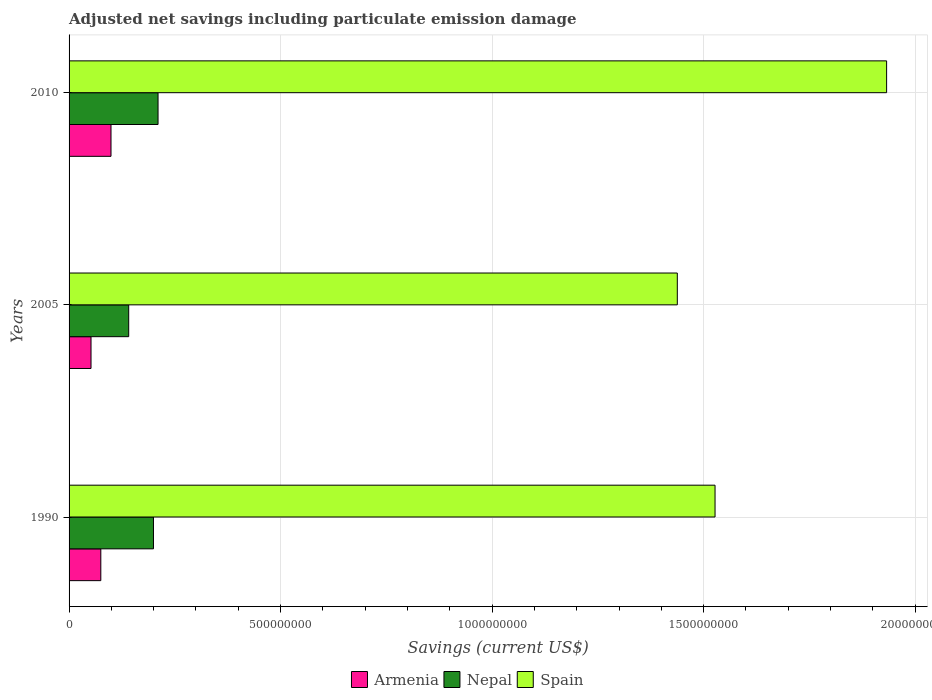How many different coloured bars are there?
Provide a short and direct response. 3. How many groups of bars are there?
Ensure brevity in your answer.  3. Are the number of bars per tick equal to the number of legend labels?
Give a very brief answer. Yes. Are the number of bars on each tick of the Y-axis equal?
Your response must be concise. Yes. How many bars are there on the 3rd tick from the top?
Keep it short and to the point. 3. How many bars are there on the 2nd tick from the bottom?
Your answer should be very brief. 3. What is the label of the 1st group of bars from the top?
Provide a succinct answer. 2010. In how many cases, is the number of bars for a given year not equal to the number of legend labels?
Keep it short and to the point. 0. What is the net savings in Armenia in 1990?
Your answer should be compact. 7.50e+07. Across all years, what is the maximum net savings in Armenia?
Your response must be concise. 9.91e+07. Across all years, what is the minimum net savings in Armenia?
Make the answer very short. 5.19e+07. In which year was the net savings in Spain maximum?
Ensure brevity in your answer.  2010. What is the total net savings in Armenia in the graph?
Provide a short and direct response. 2.26e+08. What is the difference between the net savings in Spain in 1990 and that in 2010?
Your response must be concise. -4.06e+08. What is the difference between the net savings in Armenia in 1990 and the net savings in Spain in 2010?
Make the answer very short. -1.86e+09. What is the average net savings in Nepal per year?
Your answer should be very brief. 1.84e+08. In the year 2010, what is the difference between the net savings in Nepal and net savings in Armenia?
Your response must be concise. 1.11e+08. In how many years, is the net savings in Spain greater than 1400000000 US$?
Offer a very short reply. 3. What is the ratio of the net savings in Nepal in 1990 to that in 2005?
Offer a terse response. 1.42. Is the difference between the net savings in Nepal in 2005 and 2010 greater than the difference between the net savings in Armenia in 2005 and 2010?
Offer a very short reply. No. What is the difference between the highest and the second highest net savings in Armenia?
Keep it short and to the point. 2.41e+07. What is the difference between the highest and the lowest net savings in Spain?
Offer a terse response. 4.95e+08. Is the sum of the net savings in Spain in 2005 and 2010 greater than the maximum net savings in Nepal across all years?
Provide a short and direct response. Yes. What does the 3rd bar from the top in 2005 represents?
Your answer should be compact. Armenia. What does the 2nd bar from the bottom in 1990 represents?
Provide a succinct answer. Nepal. Is it the case that in every year, the sum of the net savings in Spain and net savings in Armenia is greater than the net savings in Nepal?
Provide a succinct answer. Yes. How many years are there in the graph?
Ensure brevity in your answer.  3. What is the difference between two consecutive major ticks on the X-axis?
Make the answer very short. 5.00e+08. Where does the legend appear in the graph?
Offer a very short reply. Bottom center. How many legend labels are there?
Offer a very short reply. 3. How are the legend labels stacked?
Your answer should be compact. Horizontal. What is the title of the graph?
Give a very brief answer. Adjusted net savings including particulate emission damage. Does "Suriname" appear as one of the legend labels in the graph?
Your answer should be very brief. No. What is the label or title of the X-axis?
Offer a terse response. Savings (current US$). What is the label or title of the Y-axis?
Offer a terse response. Years. What is the Savings (current US$) of Armenia in 1990?
Make the answer very short. 7.50e+07. What is the Savings (current US$) in Nepal in 1990?
Make the answer very short. 2.00e+08. What is the Savings (current US$) in Spain in 1990?
Offer a very short reply. 1.53e+09. What is the Savings (current US$) of Armenia in 2005?
Ensure brevity in your answer.  5.19e+07. What is the Savings (current US$) of Nepal in 2005?
Make the answer very short. 1.41e+08. What is the Savings (current US$) in Spain in 2005?
Your answer should be very brief. 1.44e+09. What is the Savings (current US$) in Armenia in 2010?
Make the answer very short. 9.91e+07. What is the Savings (current US$) of Nepal in 2010?
Provide a succinct answer. 2.10e+08. What is the Savings (current US$) in Spain in 2010?
Provide a short and direct response. 1.93e+09. Across all years, what is the maximum Savings (current US$) in Armenia?
Your answer should be very brief. 9.91e+07. Across all years, what is the maximum Savings (current US$) in Nepal?
Offer a terse response. 2.10e+08. Across all years, what is the maximum Savings (current US$) in Spain?
Make the answer very short. 1.93e+09. Across all years, what is the minimum Savings (current US$) in Armenia?
Provide a succinct answer. 5.19e+07. Across all years, what is the minimum Savings (current US$) in Nepal?
Keep it short and to the point. 1.41e+08. Across all years, what is the minimum Savings (current US$) of Spain?
Ensure brevity in your answer.  1.44e+09. What is the total Savings (current US$) of Armenia in the graph?
Offer a terse response. 2.26e+08. What is the total Savings (current US$) in Nepal in the graph?
Keep it short and to the point. 5.51e+08. What is the total Savings (current US$) of Spain in the graph?
Keep it short and to the point. 4.90e+09. What is the difference between the Savings (current US$) of Armenia in 1990 and that in 2005?
Provide a short and direct response. 2.32e+07. What is the difference between the Savings (current US$) in Nepal in 1990 and that in 2005?
Make the answer very short. 5.85e+07. What is the difference between the Savings (current US$) of Spain in 1990 and that in 2005?
Make the answer very short. 8.92e+07. What is the difference between the Savings (current US$) in Armenia in 1990 and that in 2010?
Ensure brevity in your answer.  -2.41e+07. What is the difference between the Savings (current US$) in Nepal in 1990 and that in 2010?
Offer a very short reply. -1.08e+07. What is the difference between the Savings (current US$) of Spain in 1990 and that in 2010?
Provide a succinct answer. -4.06e+08. What is the difference between the Savings (current US$) of Armenia in 2005 and that in 2010?
Offer a terse response. -4.72e+07. What is the difference between the Savings (current US$) in Nepal in 2005 and that in 2010?
Your answer should be compact. -6.94e+07. What is the difference between the Savings (current US$) of Spain in 2005 and that in 2010?
Offer a very short reply. -4.95e+08. What is the difference between the Savings (current US$) of Armenia in 1990 and the Savings (current US$) of Nepal in 2005?
Make the answer very short. -6.59e+07. What is the difference between the Savings (current US$) of Armenia in 1990 and the Savings (current US$) of Spain in 2005?
Your answer should be very brief. -1.36e+09. What is the difference between the Savings (current US$) of Nepal in 1990 and the Savings (current US$) of Spain in 2005?
Offer a terse response. -1.24e+09. What is the difference between the Savings (current US$) of Armenia in 1990 and the Savings (current US$) of Nepal in 2010?
Offer a very short reply. -1.35e+08. What is the difference between the Savings (current US$) of Armenia in 1990 and the Savings (current US$) of Spain in 2010?
Provide a succinct answer. -1.86e+09. What is the difference between the Savings (current US$) in Nepal in 1990 and the Savings (current US$) in Spain in 2010?
Offer a terse response. -1.73e+09. What is the difference between the Savings (current US$) of Armenia in 2005 and the Savings (current US$) of Nepal in 2010?
Ensure brevity in your answer.  -1.58e+08. What is the difference between the Savings (current US$) of Armenia in 2005 and the Savings (current US$) of Spain in 2010?
Offer a very short reply. -1.88e+09. What is the difference between the Savings (current US$) of Nepal in 2005 and the Savings (current US$) of Spain in 2010?
Your answer should be very brief. -1.79e+09. What is the average Savings (current US$) of Armenia per year?
Give a very brief answer. 7.53e+07. What is the average Savings (current US$) in Nepal per year?
Your answer should be compact. 1.84e+08. What is the average Savings (current US$) of Spain per year?
Keep it short and to the point. 1.63e+09. In the year 1990, what is the difference between the Savings (current US$) in Armenia and Savings (current US$) in Nepal?
Make the answer very short. -1.24e+08. In the year 1990, what is the difference between the Savings (current US$) of Armenia and Savings (current US$) of Spain?
Your answer should be very brief. -1.45e+09. In the year 1990, what is the difference between the Savings (current US$) of Nepal and Savings (current US$) of Spain?
Your response must be concise. -1.33e+09. In the year 2005, what is the difference between the Savings (current US$) in Armenia and Savings (current US$) in Nepal?
Give a very brief answer. -8.91e+07. In the year 2005, what is the difference between the Savings (current US$) in Armenia and Savings (current US$) in Spain?
Offer a very short reply. -1.39e+09. In the year 2005, what is the difference between the Savings (current US$) in Nepal and Savings (current US$) in Spain?
Ensure brevity in your answer.  -1.30e+09. In the year 2010, what is the difference between the Savings (current US$) in Armenia and Savings (current US$) in Nepal?
Give a very brief answer. -1.11e+08. In the year 2010, what is the difference between the Savings (current US$) of Armenia and Savings (current US$) of Spain?
Your response must be concise. -1.83e+09. In the year 2010, what is the difference between the Savings (current US$) of Nepal and Savings (current US$) of Spain?
Your response must be concise. -1.72e+09. What is the ratio of the Savings (current US$) of Armenia in 1990 to that in 2005?
Provide a succinct answer. 1.45. What is the ratio of the Savings (current US$) of Nepal in 1990 to that in 2005?
Your answer should be compact. 1.42. What is the ratio of the Savings (current US$) of Spain in 1990 to that in 2005?
Ensure brevity in your answer.  1.06. What is the ratio of the Savings (current US$) in Armenia in 1990 to that in 2010?
Your answer should be very brief. 0.76. What is the ratio of the Savings (current US$) of Nepal in 1990 to that in 2010?
Make the answer very short. 0.95. What is the ratio of the Savings (current US$) in Spain in 1990 to that in 2010?
Keep it short and to the point. 0.79. What is the ratio of the Savings (current US$) of Armenia in 2005 to that in 2010?
Offer a terse response. 0.52. What is the ratio of the Savings (current US$) in Nepal in 2005 to that in 2010?
Your answer should be very brief. 0.67. What is the ratio of the Savings (current US$) in Spain in 2005 to that in 2010?
Give a very brief answer. 0.74. What is the difference between the highest and the second highest Savings (current US$) in Armenia?
Ensure brevity in your answer.  2.41e+07. What is the difference between the highest and the second highest Savings (current US$) in Nepal?
Provide a short and direct response. 1.08e+07. What is the difference between the highest and the second highest Savings (current US$) of Spain?
Your answer should be very brief. 4.06e+08. What is the difference between the highest and the lowest Savings (current US$) in Armenia?
Offer a very short reply. 4.72e+07. What is the difference between the highest and the lowest Savings (current US$) of Nepal?
Provide a short and direct response. 6.94e+07. What is the difference between the highest and the lowest Savings (current US$) in Spain?
Provide a short and direct response. 4.95e+08. 